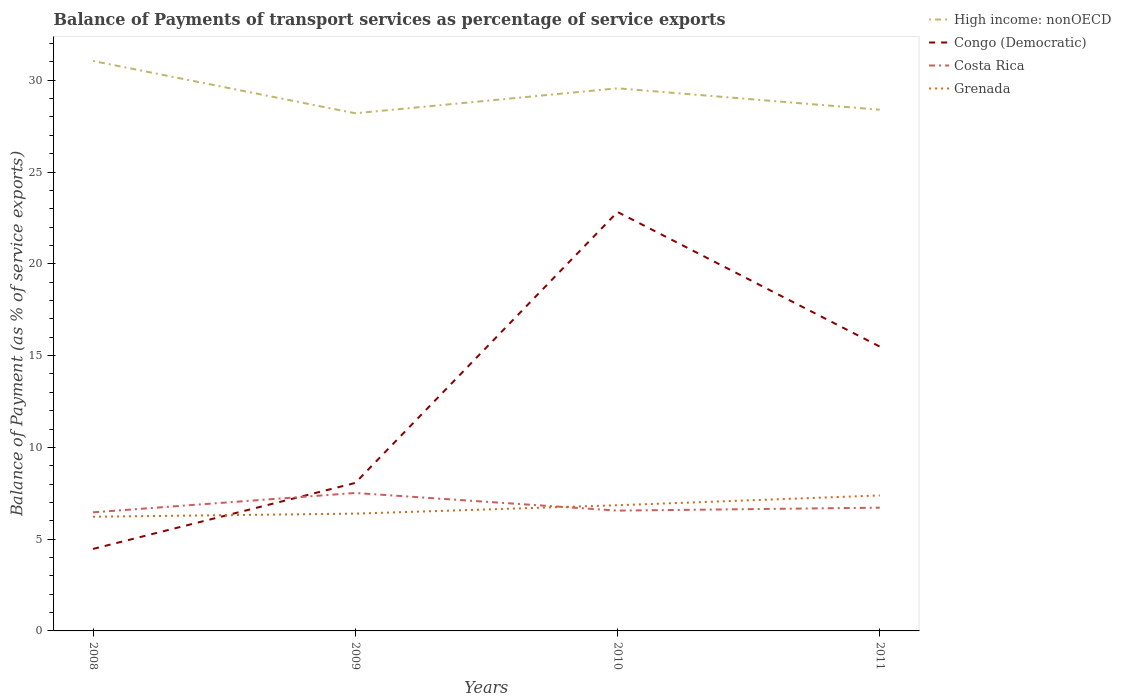How many different coloured lines are there?
Provide a succinct answer. 4. Is the number of lines equal to the number of legend labels?
Keep it short and to the point. Yes. Across all years, what is the maximum balance of payments of transport services in High income: nonOECD?
Offer a terse response. 28.2. In which year was the balance of payments of transport services in High income: nonOECD maximum?
Offer a very short reply. 2009. What is the total balance of payments of transport services in High income: nonOECD in the graph?
Give a very brief answer. 1.17. What is the difference between the highest and the second highest balance of payments of transport services in Congo (Democratic)?
Ensure brevity in your answer.  18.36. Is the balance of payments of transport services in Costa Rica strictly greater than the balance of payments of transport services in Grenada over the years?
Make the answer very short. No. How many lines are there?
Your response must be concise. 4. How many years are there in the graph?
Your response must be concise. 4. How are the legend labels stacked?
Offer a very short reply. Vertical. What is the title of the graph?
Offer a terse response. Balance of Payments of transport services as percentage of service exports. What is the label or title of the Y-axis?
Your answer should be compact. Balance of Payment (as % of service exports). What is the Balance of Payment (as % of service exports) in High income: nonOECD in 2008?
Provide a succinct answer. 31.05. What is the Balance of Payment (as % of service exports) of Congo (Democratic) in 2008?
Your answer should be compact. 4.47. What is the Balance of Payment (as % of service exports) in Costa Rica in 2008?
Give a very brief answer. 6.46. What is the Balance of Payment (as % of service exports) in Grenada in 2008?
Give a very brief answer. 6.22. What is the Balance of Payment (as % of service exports) of High income: nonOECD in 2009?
Make the answer very short. 28.2. What is the Balance of Payment (as % of service exports) in Congo (Democratic) in 2009?
Ensure brevity in your answer.  8.06. What is the Balance of Payment (as % of service exports) in Costa Rica in 2009?
Your answer should be very brief. 7.52. What is the Balance of Payment (as % of service exports) of Grenada in 2009?
Make the answer very short. 6.39. What is the Balance of Payment (as % of service exports) of High income: nonOECD in 2010?
Your response must be concise. 29.56. What is the Balance of Payment (as % of service exports) in Congo (Democratic) in 2010?
Keep it short and to the point. 22.83. What is the Balance of Payment (as % of service exports) of Costa Rica in 2010?
Ensure brevity in your answer.  6.55. What is the Balance of Payment (as % of service exports) in Grenada in 2010?
Your answer should be compact. 6.85. What is the Balance of Payment (as % of service exports) of High income: nonOECD in 2011?
Your answer should be compact. 28.4. What is the Balance of Payment (as % of service exports) of Congo (Democratic) in 2011?
Make the answer very short. 15.49. What is the Balance of Payment (as % of service exports) in Costa Rica in 2011?
Offer a very short reply. 6.71. What is the Balance of Payment (as % of service exports) of Grenada in 2011?
Your answer should be very brief. 7.38. Across all years, what is the maximum Balance of Payment (as % of service exports) of High income: nonOECD?
Give a very brief answer. 31.05. Across all years, what is the maximum Balance of Payment (as % of service exports) of Congo (Democratic)?
Keep it short and to the point. 22.83. Across all years, what is the maximum Balance of Payment (as % of service exports) of Costa Rica?
Offer a terse response. 7.52. Across all years, what is the maximum Balance of Payment (as % of service exports) of Grenada?
Offer a very short reply. 7.38. Across all years, what is the minimum Balance of Payment (as % of service exports) of High income: nonOECD?
Keep it short and to the point. 28.2. Across all years, what is the minimum Balance of Payment (as % of service exports) in Congo (Democratic)?
Make the answer very short. 4.47. Across all years, what is the minimum Balance of Payment (as % of service exports) in Costa Rica?
Give a very brief answer. 6.46. Across all years, what is the minimum Balance of Payment (as % of service exports) in Grenada?
Offer a terse response. 6.22. What is the total Balance of Payment (as % of service exports) of High income: nonOECD in the graph?
Make the answer very short. 117.21. What is the total Balance of Payment (as % of service exports) of Congo (Democratic) in the graph?
Your answer should be compact. 50.85. What is the total Balance of Payment (as % of service exports) in Costa Rica in the graph?
Provide a succinct answer. 27.25. What is the total Balance of Payment (as % of service exports) in Grenada in the graph?
Make the answer very short. 26.84. What is the difference between the Balance of Payment (as % of service exports) of High income: nonOECD in 2008 and that in 2009?
Make the answer very short. 2.85. What is the difference between the Balance of Payment (as % of service exports) of Congo (Democratic) in 2008 and that in 2009?
Give a very brief answer. -3.6. What is the difference between the Balance of Payment (as % of service exports) in Costa Rica in 2008 and that in 2009?
Give a very brief answer. -1.05. What is the difference between the Balance of Payment (as % of service exports) of Grenada in 2008 and that in 2009?
Your answer should be very brief. -0.17. What is the difference between the Balance of Payment (as % of service exports) of High income: nonOECD in 2008 and that in 2010?
Your response must be concise. 1.49. What is the difference between the Balance of Payment (as % of service exports) of Congo (Democratic) in 2008 and that in 2010?
Ensure brevity in your answer.  -18.36. What is the difference between the Balance of Payment (as % of service exports) of Costa Rica in 2008 and that in 2010?
Your answer should be very brief. -0.09. What is the difference between the Balance of Payment (as % of service exports) of Grenada in 2008 and that in 2010?
Offer a terse response. -0.63. What is the difference between the Balance of Payment (as % of service exports) in High income: nonOECD in 2008 and that in 2011?
Ensure brevity in your answer.  2.66. What is the difference between the Balance of Payment (as % of service exports) of Congo (Democratic) in 2008 and that in 2011?
Give a very brief answer. -11.02. What is the difference between the Balance of Payment (as % of service exports) in Costa Rica in 2008 and that in 2011?
Your response must be concise. -0.25. What is the difference between the Balance of Payment (as % of service exports) in Grenada in 2008 and that in 2011?
Offer a very short reply. -1.16. What is the difference between the Balance of Payment (as % of service exports) in High income: nonOECD in 2009 and that in 2010?
Provide a succinct answer. -1.36. What is the difference between the Balance of Payment (as % of service exports) of Congo (Democratic) in 2009 and that in 2010?
Your answer should be compact. -14.76. What is the difference between the Balance of Payment (as % of service exports) of Costa Rica in 2009 and that in 2010?
Your answer should be compact. 0.96. What is the difference between the Balance of Payment (as % of service exports) in Grenada in 2009 and that in 2010?
Your response must be concise. -0.46. What is the difference between the Balance of Payment (as % of service exports) of High income: nonOECD in 2009 and that in 2011?
Offer a very short reply. -0.19. What is the difference between the Balance of Payment (as % of service exports) of Congo (Democratic) in 2009 and that in 2011?
Make the answer very short. -7.43. What is the difference between the Balance of Payment (as % of service exports) in Costa Rica in 2009 and that in 2011?
Offer a very short reply. 0.8. What is the difference between the Balance of Payment (as % of service exports) in Grenada in 2009 and that in 2011?
Keep it short and to the point. -0.99. What is the difference between the Balance of Payment (as % of service exports) in High income: nonOECD in 2010 and that in 2011?
Offer a very short reply. 1.17. What is the difference between the Balance of Payment (as % of service exports) in Congo (Democratic) in 2010 and that in 2011?
Provide a short and direct response. 7.33. What is the difference between the Balance of Payment (as % of service exports) of Costa Rica in 2010 and that in 2011?
Provide a short and direct response. -0.16. What is the difference between the Balance of Payment (as % of service exports) of Grenada in 2010 and that in 2011?
Make the answer very short. -0.53. What is the difference between the Balance of Payment (as % of service exports) in High income: nonOECD in 2008 and the Balance of Payment (as % of service exports) in Congo (Democratic) in 2009?
Offer a very short reply. 22.99. What is the difference between the Balance of Payment (as % of service exports) of High income: nonOECD in 2008 and the Balance of Payment (as % of service exports) of Costa Rica in 2009?
Provide a short and direct response. 23.54. What is the difference between the Balance of Payment (as % of service exports) in High income: nonOECD in 2008 and the Balance of Payment (as % of service exports) in Grenada in 2009?
Ensure brevity in your answer.  24.66. What is the difference between the Balance of Payment (as % of service exports) in Congo (Democratic) in 2008 and the Balance of Payment (as % of service exports) in Costa Rica in 2009?
Your response must be concise. -3.05. What is the difference between the Balance of Payment (as % of service exports) in Congo (Democratic) in 2008 and the Balance of Payment (as % of service exports) in Grenada in 2009?
Provide a succinct answer. -1.92. What is the difference between the Balance of Payment (as % of service exports) of Costa Rica in 2008 and the Balance of Payment (as % of service exports) of Grenada in 2009?
Keep it short and to the point. 0.07. What is the difference between the Balance of Payment (as % of service exports) in High income: nonOECD in 2008 and the Balance of Payment (as % of service exports) in Congo (Democratic) in 2010?
Ensure brevity in your answer.  8.23. What is the difference between the Balance of Payment (as % of service exports) of High income: nonOECD in 2008 and the Balance of Payment (as % of service exports) of Costa Rica in 2010?
Provide a succinct answer. 24.5. What is the difference between the Balance of Payment (as % of service exports) of High income: nonOECD in 2008 and the Balance of Payment (as % of service exports) of Grenada in 2010?
Give a very brief answer. 24.2. What is the difference between the Balance of Payment (as % of service exports) in Congo (Democratic) in 2008 and the Balance of Payment (as % of service exports) in Costa Rica in 2010?
Your answer should be compact. -2.09. What is the difference between the Balance of Payment (as % of service exports) of Congo (Democratic) in 2008 and the Balance of Payment (as % of service exports) of Grenada in 2010?
Your answer should be very brief. -2.38. What is the difference between the Balance of Payment (as % of service exports) in Costa Rica in 2008 and the Balance of Payment (as % of service exports) in Grenada in 2010?
Your answer should be very brief. -0.39. What is the difference between the Balance of Payment (as % of service exports) in High income: nonOECD in 2008 and the Balance of Payment (as % of service exports) in Congo (Democratic) in 2011?
Provide a succinct answer. 15.56. What is the difference between the Balance of Payment (as % of service exports) of High income: nonOECD in 2008 and the Balance of Payment (as % of service exports) of Costa Rica in 2011?
Make the answer very short. 24.34. What is the difference between the Balance of Payment (as % of service exports) in High income: nonOECD in 2008 and the Balance of Payment (as % of service exports) in Grenada in 2011?
Make the answer very short. 23.67. What is the difference between the Balance of Payment (as % of service exports) in Congo (Democratic) in 2008 and the Balance of Payment (as % of service exports) in Costa Rica in 2011?
Give a very brief answer. -2.25. What is the difference between the Balance of Payment (as % of service exports) in Congo (Democratic) in 2008 and the Balance of Payment (as % of service exports) in Grenada in 2011?
Offer a terse response. -2.91. What is the difference between the Balance of Payment (as % of service exports) in Costa Rica in 2008 and the Balance of Payment (as % of service exports) in Grenada in 2011?
Offer a very short reply. -0.92. What is the difference between the Balance of Payment (as % of service exports) of High income: nonOECD in 2009 and the Balance of Payment (as % of service exports) of Congo (Democratic) in 2010?
Give a very brief answer. 5.38. What is the difference between the Balance of Payment (as % of service exports) in High income: nonOECD in 2009 and the Balance of Payment (as % of service exports) in Costa Rica in 2010?
Your response must be concise. 21.65. What is the difference between the Balance of Payment (as % of service exports) of High income: nonOECD in 2009 and the Balance of Payment (as % of service exports) of Grenada in 2010?
Ensure brevity in your answer.  21.36. What is the difference between the Balance of Payment (as % of service exports) of Congo (Democratic) in 2009 and the Balance of Payment (as % of service exports) of Costa Rica in 2010?
Provide a succinct answer. 1.51. What is the difference between the Balance of Payment (as % of service exports) of Congo (Democratic) in 2009 and the Balance of Payment (as % of service exports) of Grenada in 2010?
Make the answer very short. 1.22. What is the difference between the Balance of Payment (as % of service exports) of Costa Rica in 2009 and the Balance of Payment (as % of service exports) of Grenada in 2010?
Your answer should be very brief. 0.67. What is the difference between the Balance of Payment (as % of service exports) of High income: nonOECD in 2009 and the Balance of Payment (as % of service exports) of Congo (Democratic) in 2011?
Keep it short and to the point. 12.71. What is the difference between the Balance of Payment (as % of service exports) of High income: nonOECD in 2009 and the Balance of Payment (as % of service exports) of Costa Rica in 2011?
Provide a short and direct response. 21.49. What is the difference between the Balance of Payment (as % of service exports) in High income: nonOECD in 2009 and the Balance of Payment (as % of service exports) in Grenada in 2011?
Your response must be concise. 20.82. What is the difference between the Balance of Payment (as % of service exports) in Congo (Democratic) in 2009 and the Balance of Payment (as % of service exports) in Costa Rica in 2011?
Your answer should be compact. 1.35. What is the difference between the Balance of Payment (as % of service exports) in Congo (Democratic) in 2009 and the Balance of Payment (as % of service exports) in Grenada in 2011?
Your answer should be very brief. 0.68. What is the difference between the Balance of Payment (as % of service exports) in Costa Rica in 2009 and the Balance of Payment (as % of service exports) in Grenada in 2011?
Ensure brevity in your answer.  0.13. What is the difference between the Balance of Payment (as % of service exports) in High income: nonOECD in 2010 and the Balance of Payment (as % of service exports) in Congo (Democratic) in 2011?
Provide a short and direct response. 14.07. What is the difference between the Balance of Payment (as % of service exports) in High income: nonOECD in 2010 and the Balance of Payment (as % of service exports) in Costa Rica in 2011?
Your answer should be compact. 22.85. What is the difference between the Balance of Payment (as % of service exports) of High income: nonOECD in 2010 and the Balance of Payment (as % of service exports) of Grenada in 2011?
Offer a very short reply. 22.18. What is the difference between the Balance of Payment (as % of service exports) in Congo (Democratic) in 2010 and the Balance of Payment (as % of service exports) in Costa Rica in 2011?
Your response must be concise. 16.11. What is the difference between the Balance of Payment (as % of service exports) in Congo (Democratic) in 2010 and the Balance of Payment (as % of service exports) in Grenada in 2011?
Your answer should be compact. 15.44. What is the difference between the Balance of Payment (as % of service exports) in Costa Rica in 2010 and the Balance of Payment (as % of service exports) in Grenada in 2011?
Keep it short and to the point. -0.83. What is the average Balance of Payment (as % of service exports) in High income: nonOECD per year?
Your response must be concise. 29.3. What is the average Balance of Payment (as % of service exports) in Congo (Democratic) per year?
Ensure brevity in your answer.  12.71. What is the average Balance of Payment (as % of service exports) of Costa Rica per year?
Your answer should be compact. 6.81. What is the average Balance of Payment (as % of service exports) in Grenada per year?
Provide a short and direct response. 6.71. In the year 2008, what is the difference between the Balance of Payment (as % of service exports) of High income: nonOECD and Balance of Payment (as % of service exports) of Congo (Democratic)?
Provide a succinct answer. 26.58. In the year 2008, what is the difference between the Balance of Payment (as % of service exports) of High income: nonOECD and Balance of Payment (as % of service exports) of Costa Rica?
Your answer should be compact. 24.59. In the year 2008, what is the difference between the Balance of Payment (as % of service exports) of High income: nonOECD and Balance of Payment (as % of service exports) of Grenada?
Give a very brief answer. 24.83. In the year 2008, what is the difference between the Balance of Payment (as % of service exports) in Congo (Democratic) and Balance of Payment (as % of service exports) in Costa Rica?
Give a very brief answer. -1.99. In the year 2008, what is the difference between the Balance of Payment (as % of service exports) of Congo (Democratic) and Balance of Payment (as % of service exports) of Grenada?
Make the answer very short. -1.75. In the year 2008, what is the difference between the Balance of Payment (as % of service exports) of Costa Rica and Balance of Payment (as % of service exports) of Grenada?
Offer a very short reply. 0.24. In the year 2009, what is the difference between the Balance of Payment (as % of service exports) of High income: nonOECD and Balance of Payment (as % of service exports) of Congo (Democratic)?
Offer a very short reply. 20.14. In the year 2009, what is the difference between the Balance of Payment (as % of service exports) in High income: nonOECD and Balance of Payment (as % of service exports) in Costa Rica?
Your answer should be compact. 20.69. In the year 2009, what is the difference between the Balance of Payment (as % of service exports) in High income: nonOECD and Balance of Payment (as % of service exports) in Grenada?
Make the answer very short. 21.81. In the year 2009, what is the difference between the Balance of Payment (as % of service exports) of Congo (Democratic) and Balance of Payment (as % of service exports) of Costa Rica?
Ensure brevity in your answer.  0.55. In the year 2009, what is the difference between the Balance of Payment (as % of service exports) of Congo (Democratic) and Balance of Payment (as % of service exports) of Grenada?
Your answer should be very brief. 1.67. In the year 2009, what is the difference between the Balance of Payment (as % of service exports) in Costa Rica and Balance of Payment (as % of service exports) in Grenada?
Ensure brevity in your answer.  1.13. In the year 2010, what is the difference between the Balance of Payment (as % of service exports) of High income: nonOECD and Balance of Payment (as % of service exports) of Congo (Democratic)?
Keep it short and to the point. 6.74. In the year 2010, what is the difference between the Balance of Payment (as % of service exports) of High income: nonOECD and Balance of Payment (as % of service exports) of Costa Rica?
Your response must be concise. 23.01. In the year 2010, what is the difference between the Balance of Payment (as % of service exports) of High income: nonOECD and Balance of Payment (as % of service exports) of Grenada?
Provide a succinct answer. 22.72. In the year 2010, what is the difference between the Balance of Payment (as % of service exports) of Congo (Democratic) and Balance of Payment (as % of service exports) of Costa Rica?
Make the answer very short. 16.27. In the year 2010, what is the difference between the Balance of Payment (as % of service exports) of Congo (Democratic) and Balance of Payment (as % of service exports) of Grenada?
Offer a terse response. 15.98. In the year 2010, what is the difference between the Balance of Payment (as % of service exports) in Costa Rica and Balance of Payment (as % of service exports) in Grenada?
Offer a terse response. -0.29. In the year 2011, what is the difference between the Balance of Payment (as % of service exports) in High income: nonOECD and Balance of Payment (as % of service exports) in Congo (Democratic)?
Keep it short and to the point. 12.9. In the year 2011, what is the difference between the Balance of Payment (as % of service exports) of High income: nonOECD and Balance of Payment (as % of service exports) of Costa Rica?
Keep it short and to the point. 21.68. In the year 2011, what is the difference between the Balance of Payment (as % of service exports) of High income: nonOECD and Balance of Payment (as % of service exports) of Grenada?
Offer a terse response. 21.02. In the year 2011, what is the difference between the Balance of Payment (as % of service exports) of Congo (Democratic) and Balance of Payment (as % of service exports) of Costa Rica?
Give a very brief answer. 8.78. In the year 2011, what is the difference between the Balance of Payment (as % of service exports) in Congo (Democratic) and Balance of Payment (as % of service exports) in Grenada?
Offer a terse response. 8.11. In the year 2011, what is the difference between the Balance of Payment (as % of service exports) in Costa Rica and Balance of Payment (as % of service exports) in Grenada?
Your response must be concise. -0.67. What is the ratio of the Balance of Payment (as % of service exports) of High income: nonOECD in 2008 to that in 2009?
Offer a terse response. 1.1. What is the ratio of the Balance of Payment (as % of service exports) of Congo (Democratic) in 2008 to that in 2009?
Offer a terse response. 0.55. What is the ratio of the Balance of Payment (as % of service exports) in Costa Rica in 2008 to that in 2009?
Offer a terse response. 0.86. What is the ratio of the Balance of Payment (as % of service exports) in Grenada in 2008 to that in 2009?
Give a very brief answer. 0.97. What is the ratio of the Balance of Payment (as % of service exports) of High income: nonOECD in 2008 to that in 2010?
Keep it short and to the point. 1.05. What is the ratio of the Balance of Payment (as % of service exports) in Congo (Democratic) in 2008 to that in 2010?
Give a very brief answer. 0.2. What is the ratio of the Balance of Payment (as % of service exports) in Costa Rica in 2008 to that in 2010?
Your response must be concise. 0.99. What is the ratio of the Balance of Payment (as % of service exports) of Grenada in 2008 to that in 2010?
Offer a very short reply. 0.91. What is the ratio of the Balance of Payment (as % of service exports) in High income: nonOECD in 2008 to that in 2011?
Your answer should be very brief. 1.09. What is the ratio of the Balance of Payment (as % of service exports) of Congo (Democratic) in 2008 to that in 2011?
Your response must be concise. 0.29. What is the ratio of the Balance of Payment (as % of service exports) in Costa Rica in 2008 to that in 2011?
Give a very brief answer. 0.96. What is the ratio of the Balance of Payment (as % of service exports) of Grenada in 2008 to that in 2011?
Give a very brief answer. 0.84. What is the ratio of the Balance of Payment (as % of service exports) in High income: nonOECD in 2009 to that in 2010?
Keep it short and to the point. 0.95. What is the ratio of the Balance of Payment (as % of service exports) of Congo (Democratic) in 2009 to that in 2010?
Keep it short and to the point. 0.35. What is the ratio of the Balance of Payment (as % of service exports) in Costa Rica in 2009 to that in 2010?
Make the answer very short. 1.15. What is the ratio of the Balance of Payment (as % of service exports) of Grenada in 2009 to that in 2010?
Offer a very short reply. 0.93. What is the ratio of the Balance of Payment (as % of service exports) in Congo (Democratic) in 2009 to that in 2011?
Ensure brevity in your answer.  0.52. What is the ratio of the Balance of Payment (as % of service exports) of Costa Rica in 2009 to that in 2011?
Provide a short and direct response. 1.12. What is the ratio of the Balance of Payment (as % of service exports) of Grenada in 2009 to that in 2011?
Provide a succinct answer. 0.87. What is the ratio of the Balance of Payment (as % of service exports) in High income: nonOECD in 2010 to that in 2011?
Offer a terse response. 1.04. What is the ratio of the Balance of Payment (as % of service exports) in Congo (Democratic) in 2010 to that in 2011?
Offer a terse response. 1.47. What is the ratio of the Balance of Payment (as % of service exports) of Costa Rica in 2010 to that in 2011?
Make the answer very short. 0.98. What is the ratio of the Balance of Payment (as % of service exports) of Grenada in 2010 to that in 2011?
Your answer should be very brief. 0.93. What is the difference between the highest and the second highest Balance of Payment (as % of service exports) of High income: nonOECD?
Your answer should be compact. 1.49. What is the difference between the highest and the second highest Balance of Payment (as % of service exports) in Congo (Democratic)?
Ensure brevity in your answer.  7.33. What is the difference between the highest and the second highest Balance of Payment (as % of service exports) of Costa Rica?
Offer a very short reply. 0.8. What is the difference between the highest and the second highest Balance of Payment (as % of service exports) of Grenada?
Ensure brevity in your answer.  0.53. What is the difference between the highest and the lowest Balance of Payment (as % of service exports) in High income: nonOECD?
Your answer should be compact. 2.85. What is the difference between the highest and the lowest Balance of Payment (as % of service exports) in Congo (Democratic)?
Make the answer very short. 18.36. What is the difference between the highest and the lowest Balance of Payment (as % of service exports) of Costa Rica?
Give a very brief answer. 1.05. What is the difference between the highest and the lowest Balance of Payment (as % of service exports) of Grenada?
Your response must be concise. 1.16. 